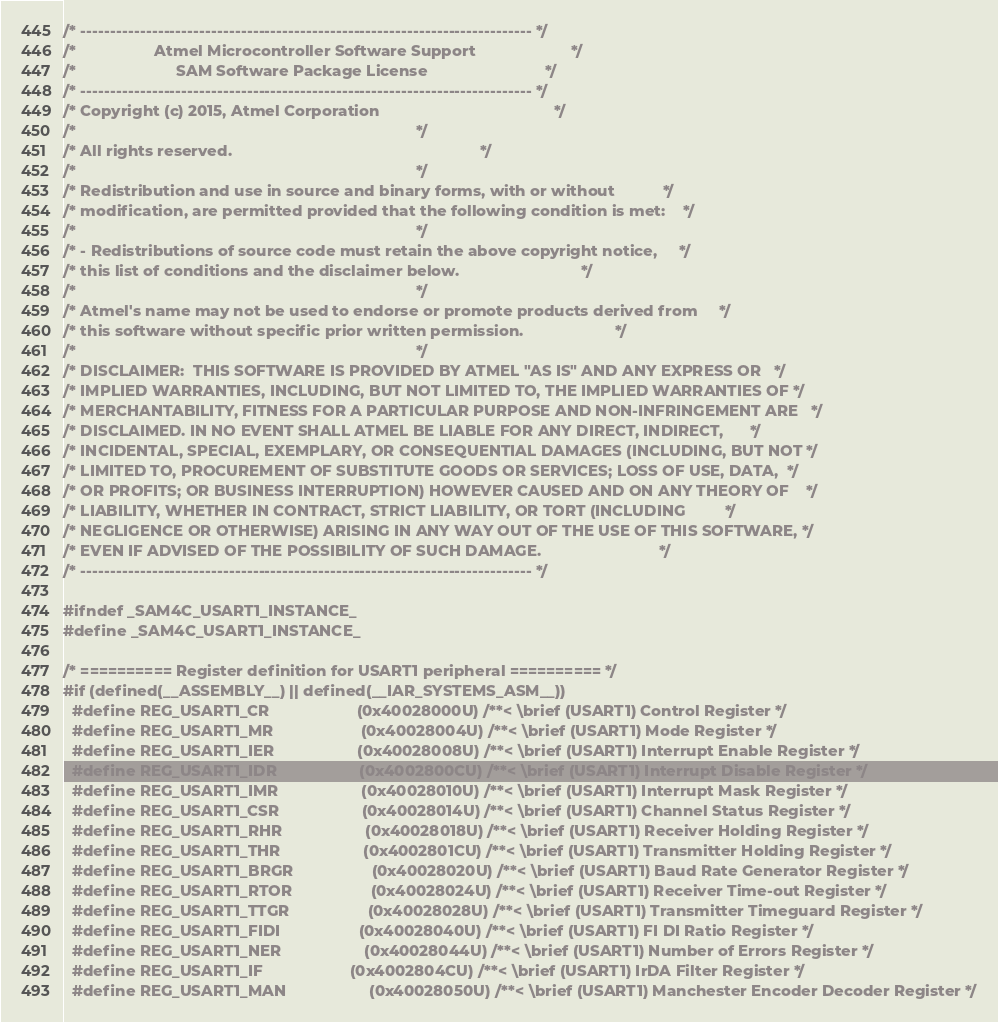Convert code to text. <code><loc_0><loc_0><loc_500><loc_500><_C_>/* ---------------------------------------------------------------------------- */
/*                  Atmel Microcontroller Software Support                      */
/*                       SAM Software Package License                           */
/* ---------------------------------------------------------------------------- */
/* Copyright (c) 2015, Atmel Corporation                                        */
/*                                                                              */
/* All rights reserved.                                                         */
/*                                                                              */
/* Redistribution and use in source and binary forms, with or without           */
/* modification, are permitted provided that the following condition is met:    */
/*                                                                              */
/* - Redistributions of source code must retain the above copyright notice,     */
/* this list of conditions and the disclaimer below.                            */
/*                                                                              */
/* Atmel's name may not be used to endorse or promote products derived from     */
/* this software without specific prior written permission.                     */
/*                                                                              */
/* DISCLAIMER:  THIS SOFTWARE IS PROVIDED BY ATMEL "AS IS" AND ANY EXPRESS OR   */
/* IMPLIED WARRANTIES, INCLUDING, BUT NOT LIMITED TO, THE IMPLIED WARRANTIES OF */
/* MERCHANTABILITY, FITNESS FOR A PARTICULAR PURPOSE AND NON-INFRINGEMENT ARE   */
/* DISCLAIMED. IN NO EVENT SHALL ATMEL BE LIABLE FOR ANY DIRECT, INDIRECT,      */
/* INCIDENTAL, SPECIAL, EXEMPLARY, OR CONSEQUENTIAL DAMAGES (INCLUDING, BUT NOT */
/* LIMITED TO, PROCUREMENT OF SUBSTITUTE GOODS OR SERVICES; LOSS OF USE, DATA,  */
/* OR PROFITS; OR BUSINESS INTERRUPTION) HOWEVER CAUSED AND ON ANY THEORY OF    */
/* LIABILITY, WHETHER IN CONTRACT, STRICT LIABILITY, OR TORT (INCLUDING         */
/* NEGLIGENCE OR OTHERWISE) ARISING IN ANY WAY OUT OF THE USE OF THIS SOFTWARE, */
/* EVEN IF ADVISED OF THE POSSIBILITY OF SUCH DAMAGE.                           */
/* ---------------------------------------------------------------------------- */

#ifndef _SAM4C_USART1_INSTANCE_
#define _SAM4C_USART1_INSTANCE_

/* ========== Register definition for USART1 peripheral ========== */
#if (defined(__ASSEMBLY__) || defined(__IAR_SYSTEMS_ASM__))
  #define REG_USART1_CR                    (0x40028000U) /**< \brief (USART1) Control Register */
  #define REG_USART1_MR                    (0x40028004U) /**< \brief (USART1) Mode Register */
  #define REG_USART1_IER                   (0x40028008U) /**< \brief (USART1) Interrupt Enable Register */
  #define REG_USART1_IDR                   (0x4002800CU) /**< \brief (USART1) Interrupt Disable Register */
  #define REG_USART1_IMR                   (0x40028010U) /**< \brief (USART1) Interrupt Mask Register */
  #define REG_USART1_CSR                   (0x40028014U) /**< \brief (USART1) Channel Status Register */
  #define REG_USART1_RHR                   (0x40028018U) /**< \brief (USART1) Receiver Holding Register */
  #define REG_USART1_THR                   (0x4002801CU) /**< \brief (USART1) Transmitter Holding Register */
  #define REG_USART1_BRGR                  (0x40028020U) /**< \brief (USART1) Baud Rate Generator Register */
  #define REG_USART1_RTOR                  (0x40028024U) /**< \brief (USART1) Receiver Time-out Register */
  #define REG_USART1_TTGR                  (0x40028028U) /**< \brief (USART1) Transmitter Timeguard Register */
  #define REG_USART1_FIDI                  (0x40028040U) /**< \brief (USART1) FI DI Ratio Register */
  #define REG_USART1_NER                   (0x40028044U) /**< \brief (USART1) Number of Errors Register */
  #define REG_USART1_IF                    (0x4002804CU) /**< \brief (USART1) IrDA Filter Register */
  #define REG_USART1_MAN                   (0x40028050U) /**< \brief (USART1) Manchester Encoder Decoder Register */</code> 